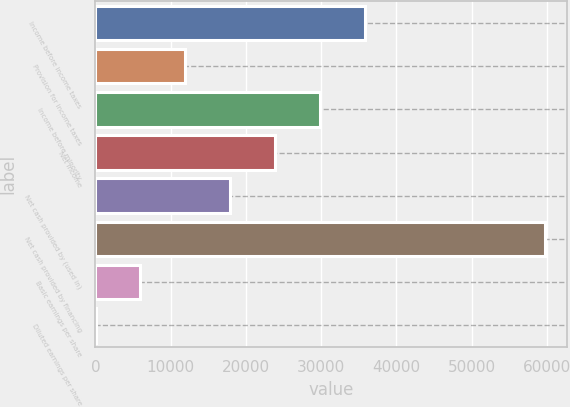Convert chart. <chart><loc_0><loc_0><loc_500><loc_500><bar_chart><fcel>Income before income taxes<fcel>Provision for income taxes<fcel>Income before minority<fcel>Net income<fcel>Net cash provided by (used in)<fcel>Net cash provided by financing<fcel>Basic earnings per share<fcel>Diluted earnings per share<nl><fcel>35859.3<fcel>11956.7<fcel>29883.7<fcel>23908<fcel>17932.4<fcel>59762<fcel>5981.02<fcel>5.35<nl></chart> 